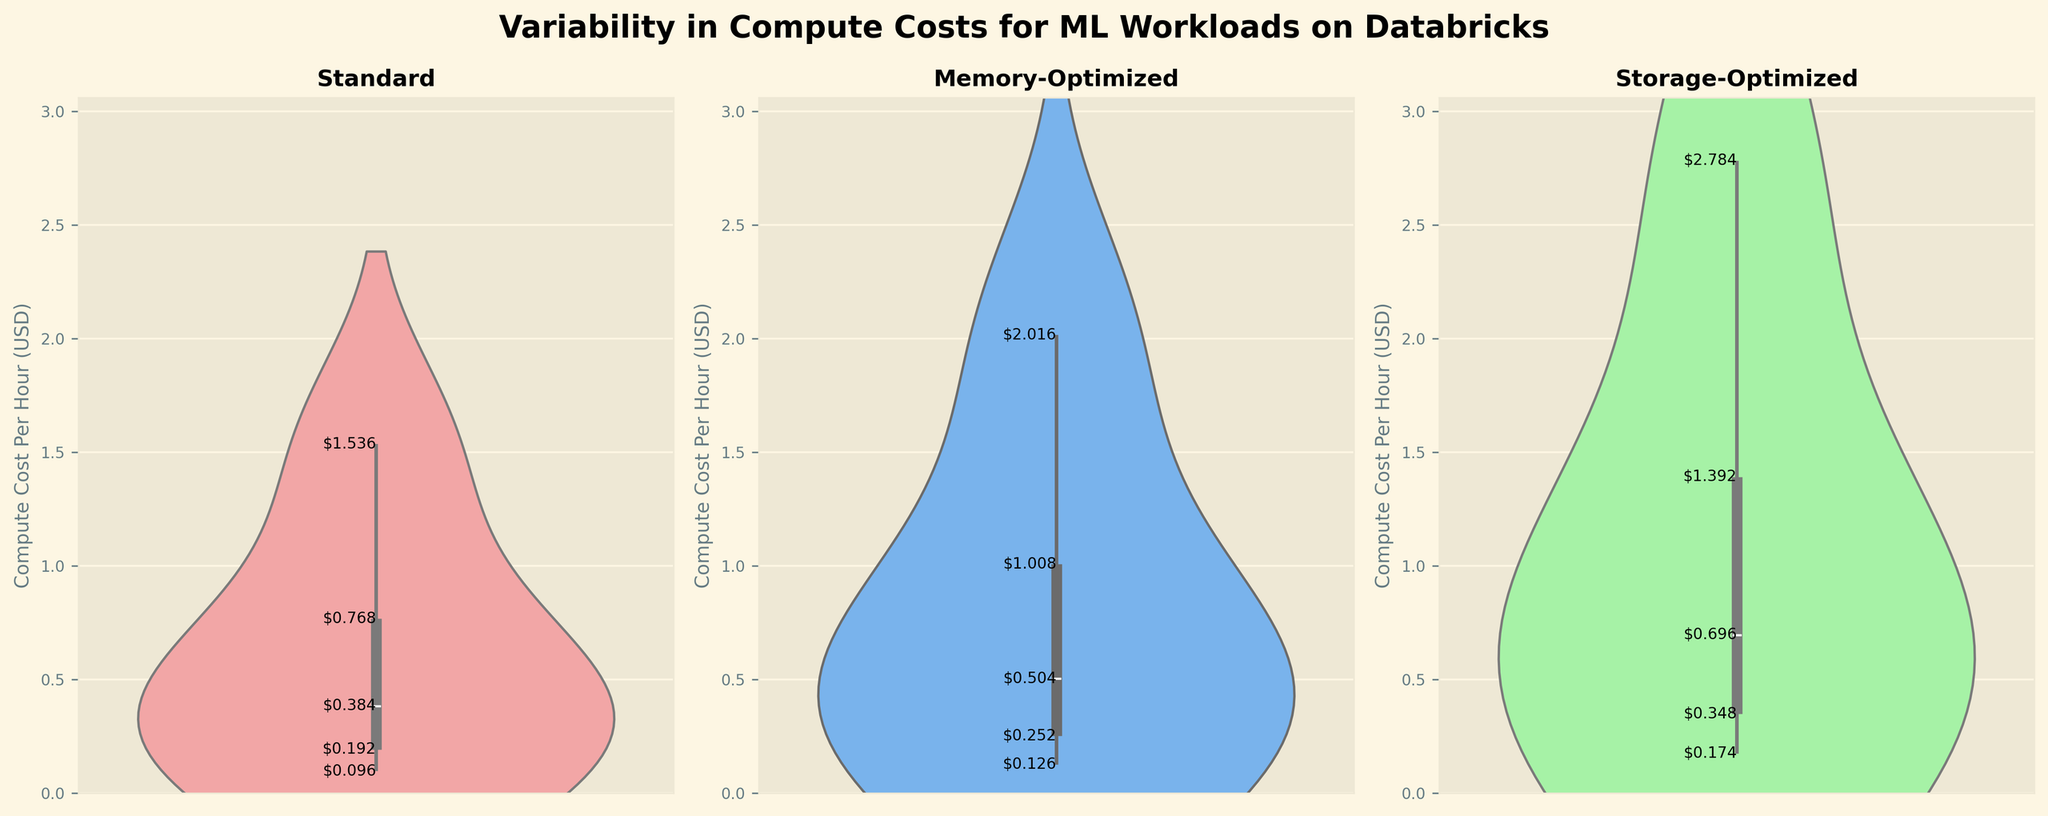What's the title and subtitle of the figure? The title is 'Variability in Compute Costs for ML Workloads on Databricks' and there is no subtitle.
Answer: Variability in Compute Costs for ML Workloads on Databricks Which instance type has the higher maximum compute cost per hour in the figure? The plot shows the vertical range of compute costs for each instance type. The Storage-Optimized violin has the highest point at around $2.784 per hour.
Answer: Storage-Optimized Which instance type has the lowest minimum compute cost per hour? The Standard instance type violin plot extends to the lowest point, reaching around $0.096 per hour.
Answer: Standard What's the range of compute costs for the Memory-Optimized instance type? The Memory-Optimized instance type violin plot spans from around $0.126 to $2.016 per hour.
Answer: $0.126 to $2.016 per hour How do the ranges of compute costs compare between Standard and Storage-Optimized instance types? The Standard instances range from about $0.096 to $1.536 per hour, while Storage-Optimized instances range from about $0.174 to $2.784 per hour.
Answer: Standard: $0.096 to $1.536, Storage-Optimized: $0.174 to $2.784 What is the median compute cost for the Standard instance type? By looking at the distribution and central tendency of the Standard instance type's violin plot, the median seems to be around $0.384 per hour.
Answer: $0.384 per hour Do Memory-Optimized instances generally have higher compute costs than Standard instances? The violin plots show that the range of compute costs for Memory-Optimized instances is generally higher than that for Standard instances, as the Memory-Optimized plot extends further upwards.
Answer: Yes Which instance type has a more evenly distributed compute cost range? From the violin plots, the Standard and Memory-Optimized instance types have more evenly spread distributions, whereas Storage-Optimized has a broader range but with more concentrated values.
Answer: Standard For which instance type do the compute costs vary the most? The Storage-Optimized instance type has the widest spread in the violin plot, indicating the highest variability in compute costs.
Answer: Storage-Optimized 